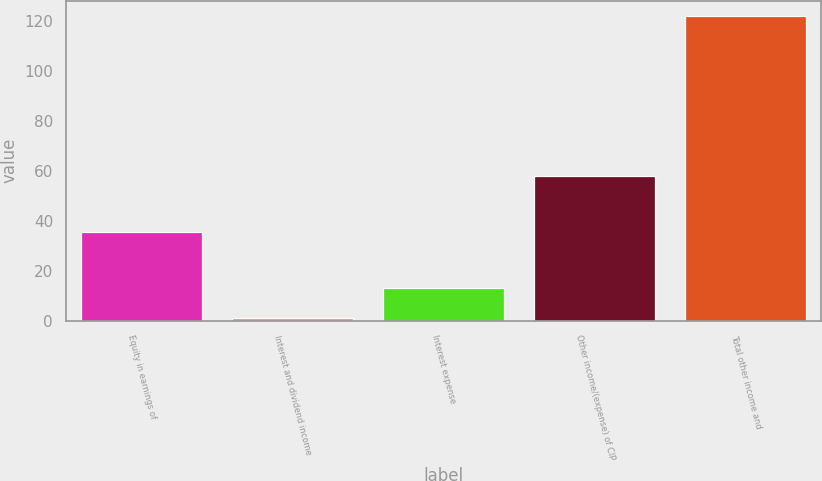Convert chart to OTSL. <chart><loc_0><loc_0><loc_500><loc_500><bar_chart><fcel>Equity in earnings of<fcel>Interest and dividend income<fcel>Interest expense<fcel>Other income/(expense) of CIP<fcel>Total other income and<nl><fcel>35.4<fcel>1.2<fcel>13.27<fcel>58.1<fcel>121.9<nl></chart> 